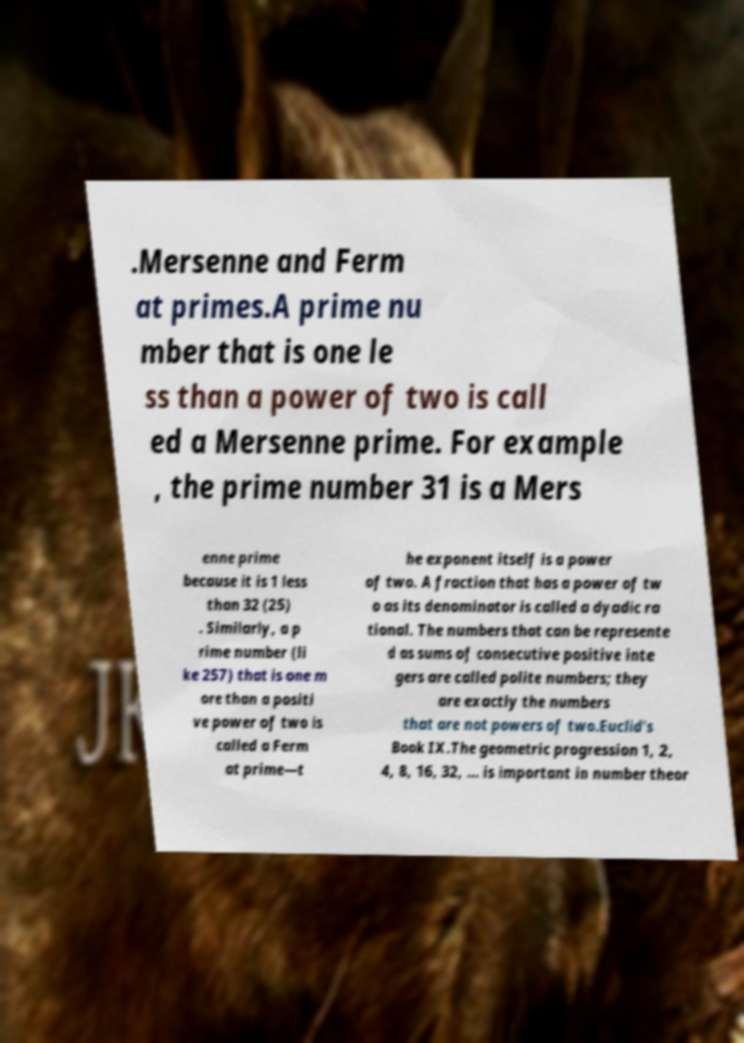There's text embedded in this image that I need extracted. Can you transcribe it verbatim? .Mersenne and Ferm at primes.A prime nu mber that is one le ss than a power of two is call ed a Mersenne prime. For example , the prime number 31 is a Mers enne prime because it is 1 less than 32 (25) . Similarly, a p rime number (li ke 257) that is one m ore than a positi ve power of two is called a Ferm at prime—t he exponent itself is a power of two. A fraction that has a power of tw o as its denominator is called a dyadic ra tional. The numbers that can be represente d as sums of consecutive positive inte gers are called polite numbers; they are exactly the numbers that are not powers of two.Euclid's Book IX.The geometric progression 1, 2, 4, 8, 16, 32, ... is important in number theor 